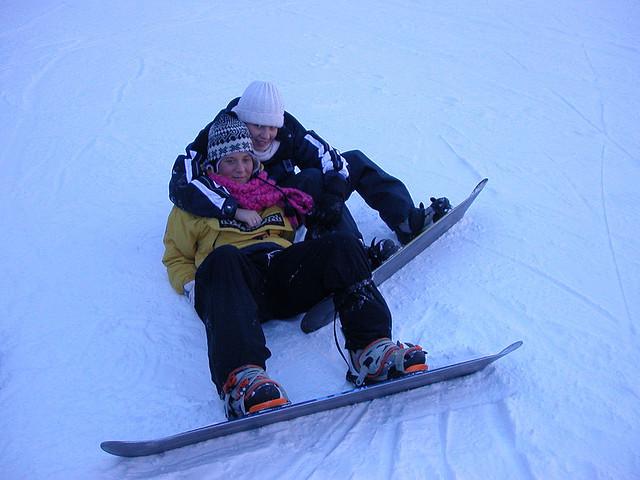Are the girls snowboarding?
Write a very short answer. Yes. What color is the girls scarf?
Answer briefly. Pink. Do the people know each other?
Short answer required. Yes. 